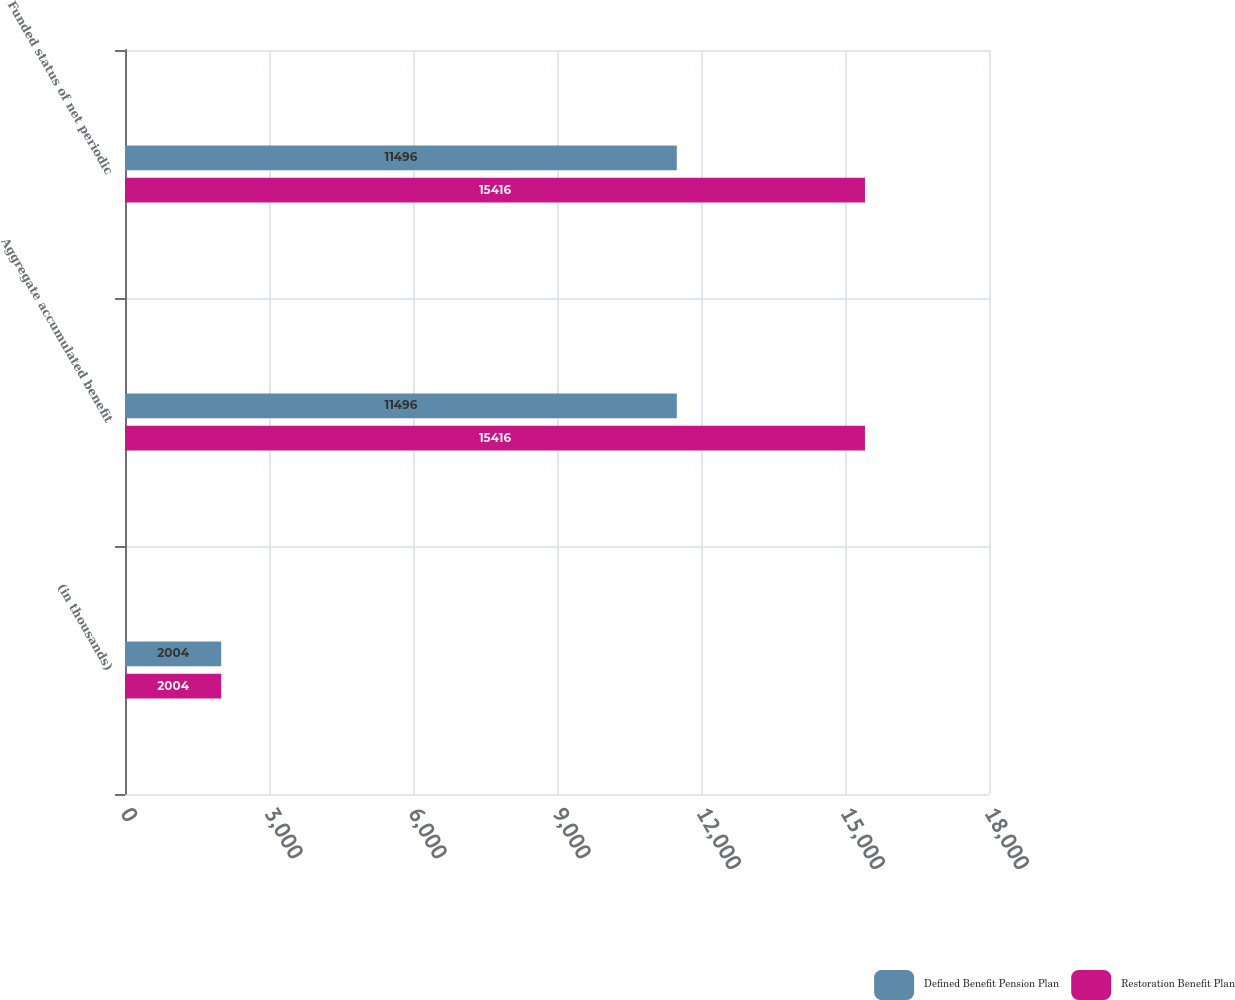Convert chart. <chart><loc_0><loc_0><loc_500><loc_500><stacked_bar_chart><ecel><fcel>(in thousands)<fcel>Aggregate accumulated benefit<fcel>Funded status of net periodic<nl><fcel>Defined Benefit Pension Plan<fcel>2004<fcel>11496<fcel>11496<nl><fcel>Restoration Benefit Plan<fcel>2004<fcel>15416<fcel>15416<nl></chart> 